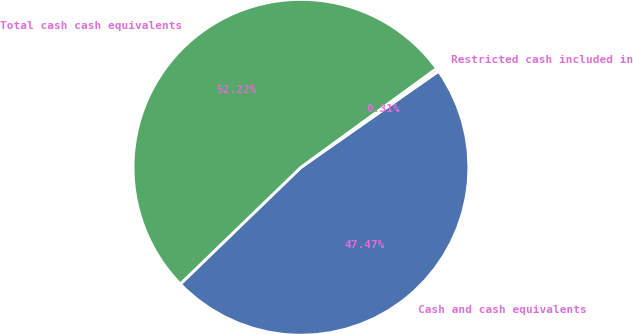<chart> <loc_0><loc_0><loc_500><loc_500><pie_chart><fcel>Cash and cash equivalents<fcel>Restricted cash included in<fcel>Total cash cash equivalents<nl><fcel>47.47%<fcel>0.31%<fcel>52.22%<nl></chart> 